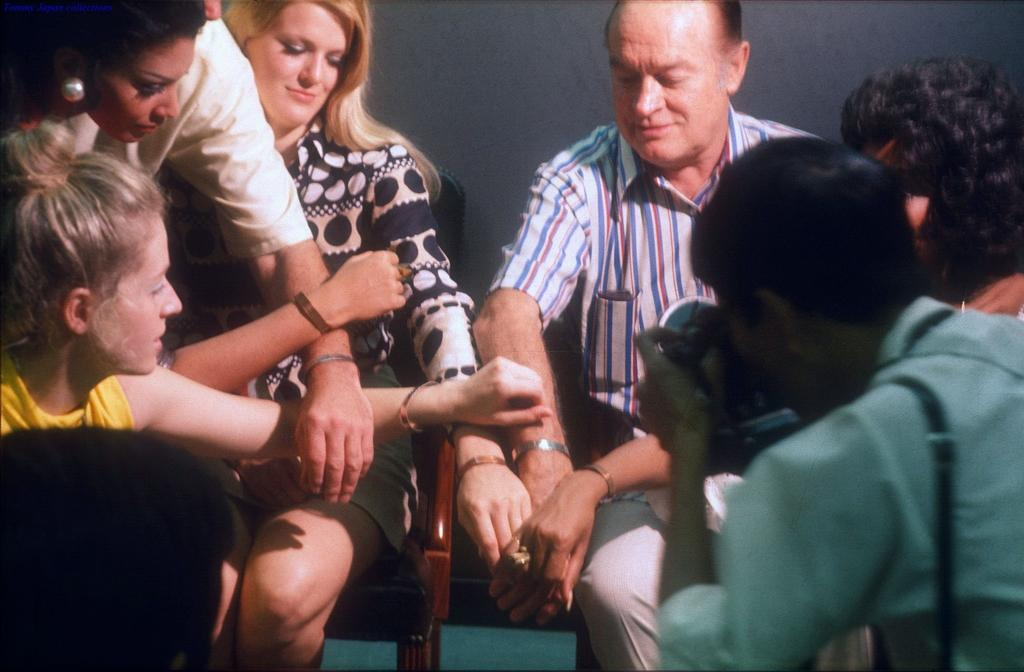How many people are in the image? There is a group of people in the image. What are some of the people in the image doing? Some people are sitting in chairs. What can be seen in the background of the image? There is a wall in the background of the image. How many dinosaurs can be seen climbing the hill in the image? There are no dinosaurs or hills present in the image. 